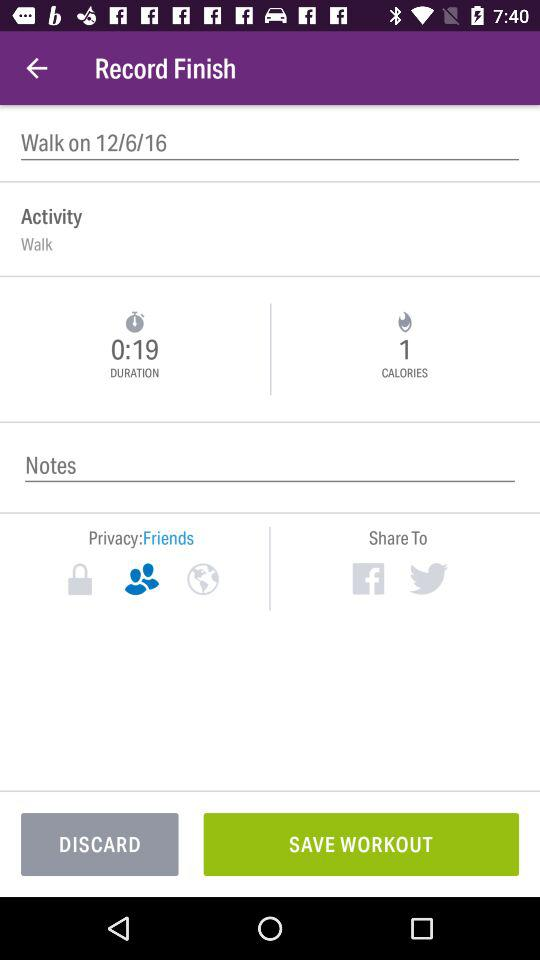How long did this workout last?
Answer the question using a single word or phrase. 0:19 